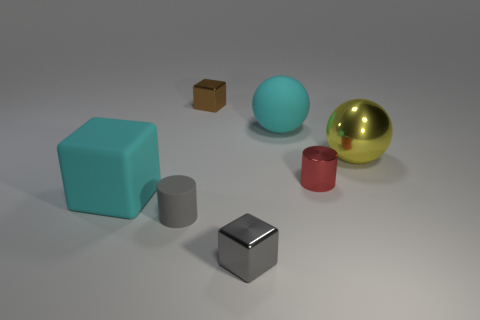Add 1 small gray cylinders. How many objects exist? 8 Subtract all spheres. How many objects are left? 5 Subtract all large cyan blocks. Subtract all small red objects. How many objects are left? 5 Add 1 yellow metallic balls. How many yellow metallic balls are left? 2 Add 2 cyan rubber balls. How many cyan rubber balls exist? 3 Subtract 0 gray balls. How many objects are left? 7 